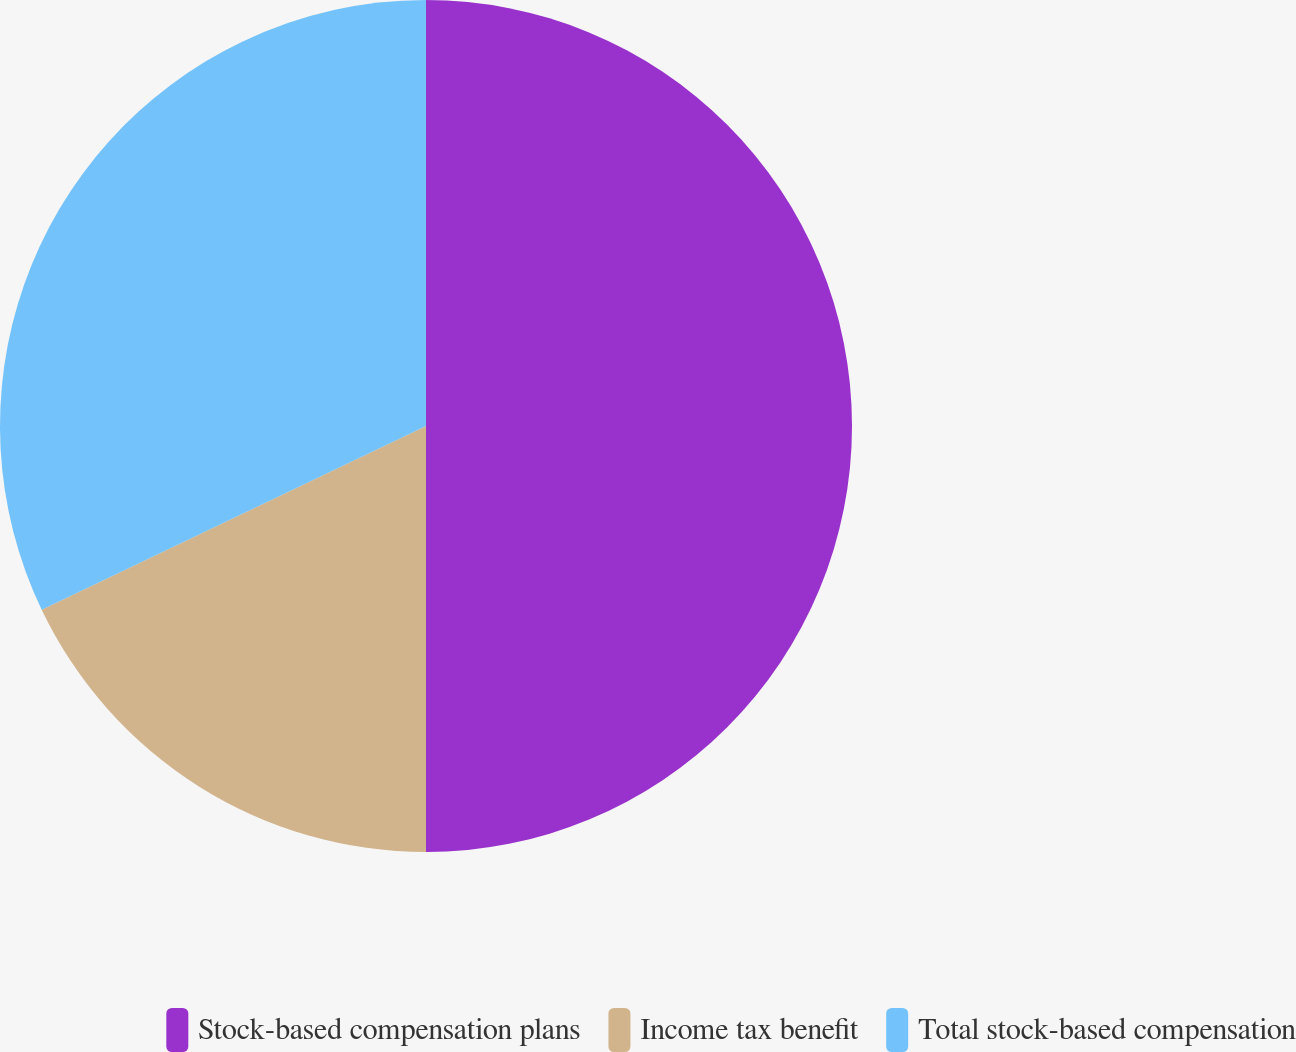Convert chart to OTSL. <chart><loc_0><loc_0><loc_500><loc_500><pie_chart><fcel>Stock-based compensation plans<fcel>Income tax benefit<fcel>Total stock-based compensation<nl><fcel>50.0%<fcel>17.9%<fcel>32.1%<nl></chart> 